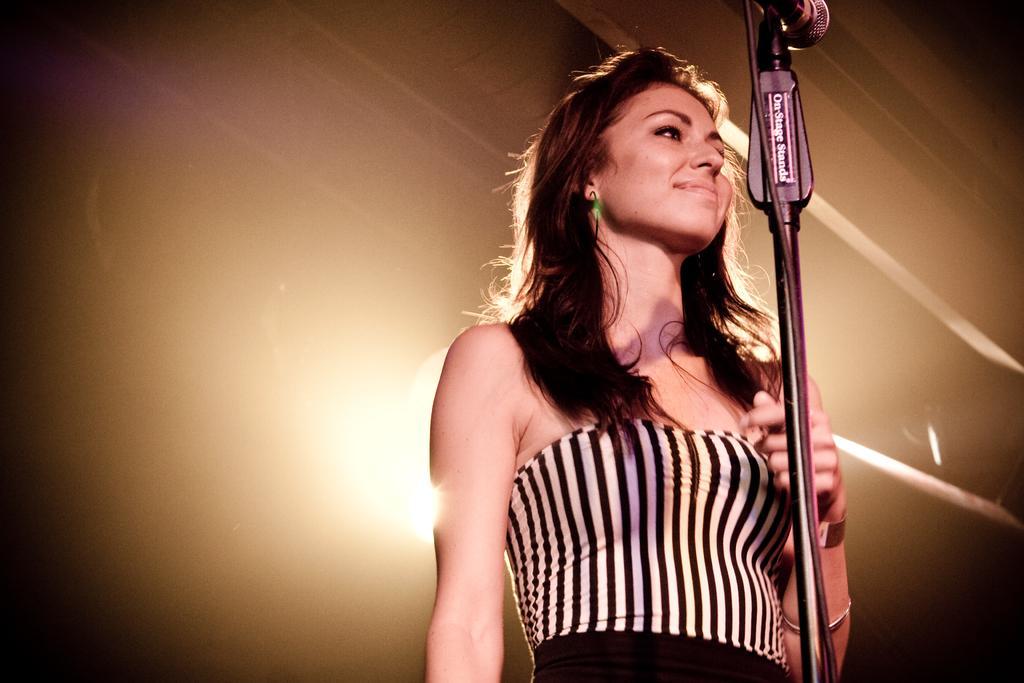Describe this image in one or two sentences. In this picture I can see there is a woman standing, she is wearing a black and white dress and there is a microphone in front of her and in the backdrop there is a light. 